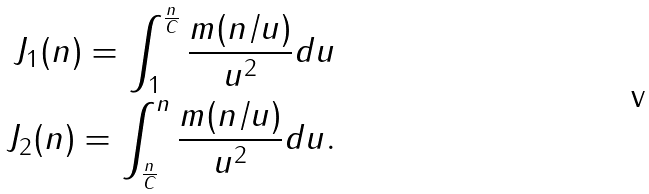<formula> <loc_0><loc_0><loc_500><loc_500>J _ { 1 } ( n ) = \int _ { 1 } ^ { \frac { n } { C } } \frac { m ( n / u ) } { u ^ { 2 } } d u \\ J _ { 2 } ( n ) = \int _ { \frac { n } { C } } ^ { n } \frac { m ( n / u ) } { u ^ { 2 } } d u .</formula> 